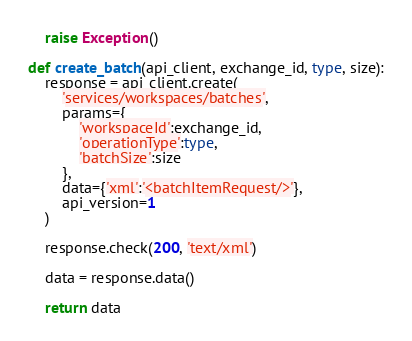Convert code to text. <code><loc_0><loc_0><loc_500><loc_500><_Python_>    raise Exception()

def create_batch(api_client, exchange_id, type, size):
    response = api_client.create(
        'services/workspaces/batches', 
        params={
            'workspaceId':exchange_id,
            'operationType':type,
            'batchSize':size
        }, 
        data={'xml':'<batchItemRequest/>'},
        api_version=1
    )
    
    response.check(200, 'text/xml')
    
    data = response.data()
    
    return data</code> 